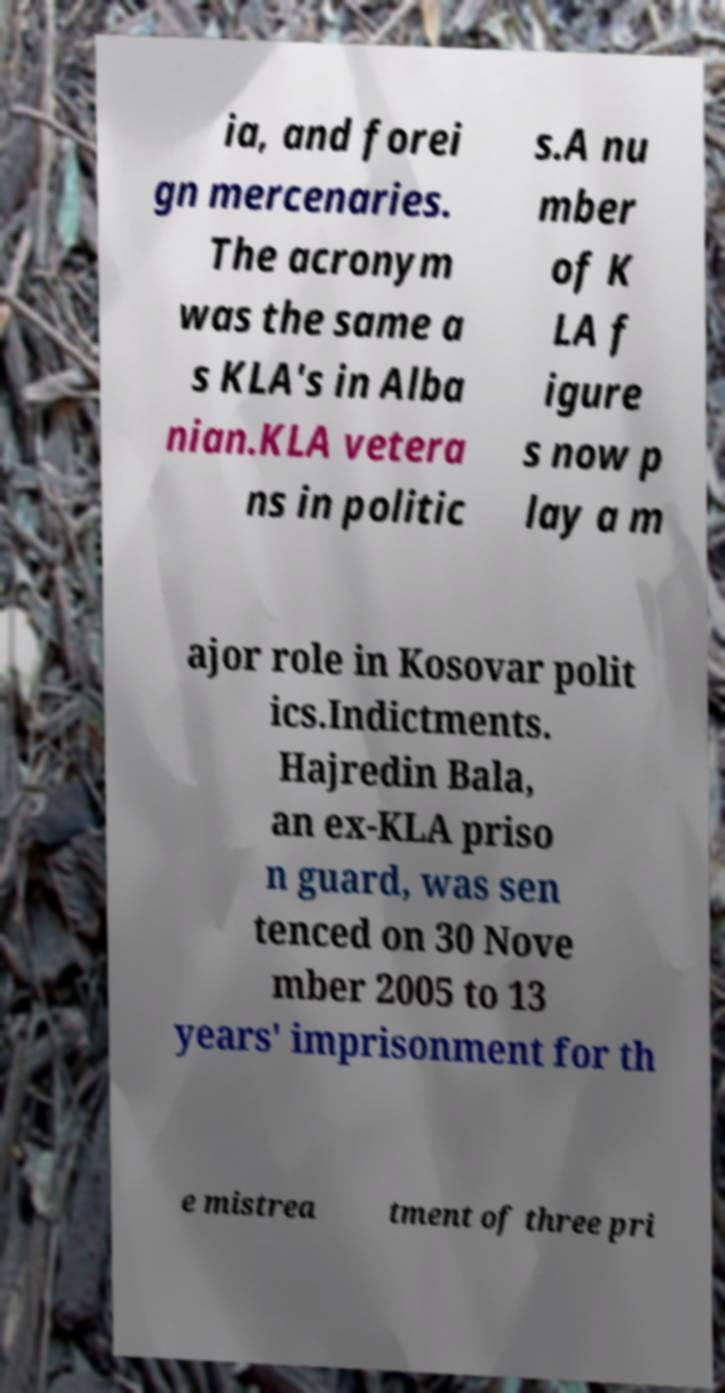I need the written content from this picture converted into text. Can you do that? ia, and forei gn mercenaries. The acronym was the same a s KLA's in Alba nian.KLA vetera ns in politic s.A nu mber of K LA f igure s now p lay a m ajor role in Kosovar polit ics.Indictments. Hajredin Bala, an ex-KLA priso n guard, was sen tenced on 30 Nove mber 2005 to 13 years' imprisonment for th e mistrea tment of three pri 